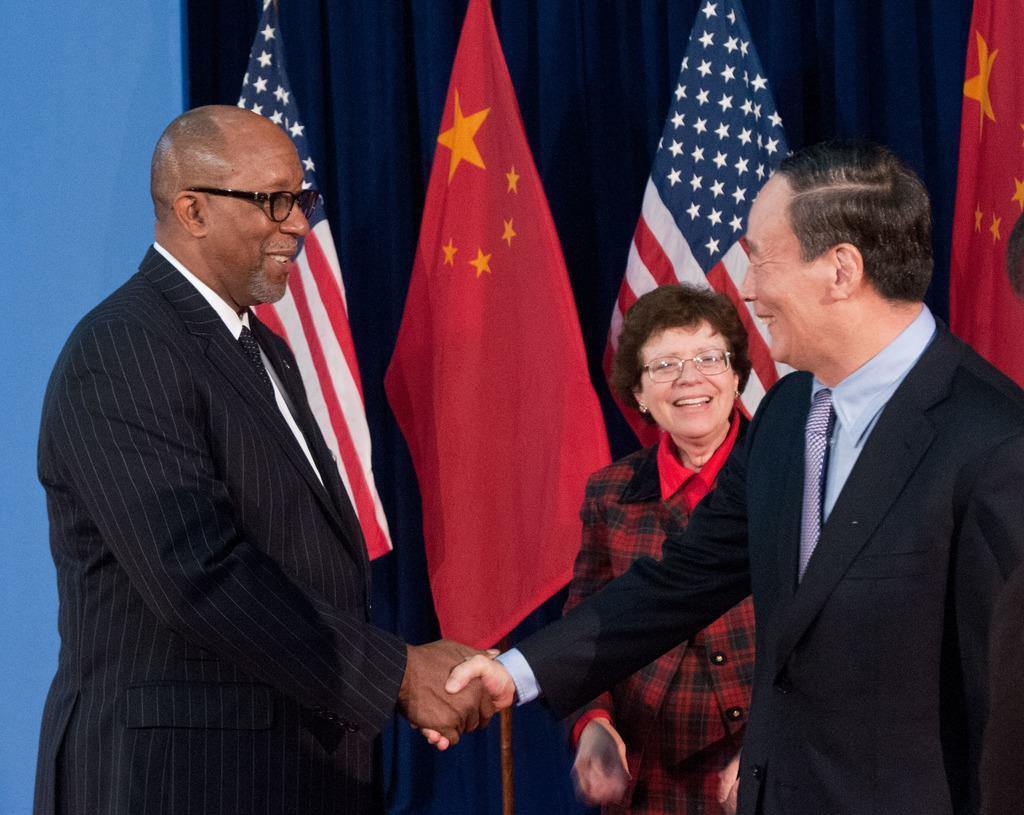Please provide a concise description of this image. In the foreground I can see two persons are shaking their hands and one person is standing on the floor. In the background I can see flags, curtains and wall. This image is taken may be in a hall. 